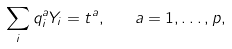Convert formula to latex. <formula><loc_0><loc_0><loc_500><loc_500>\sum _ { i } q _ { i } ^ { a } Y _ { i } = t ^ { a } , \quad a = 1 , \dots , p ,</formula> 